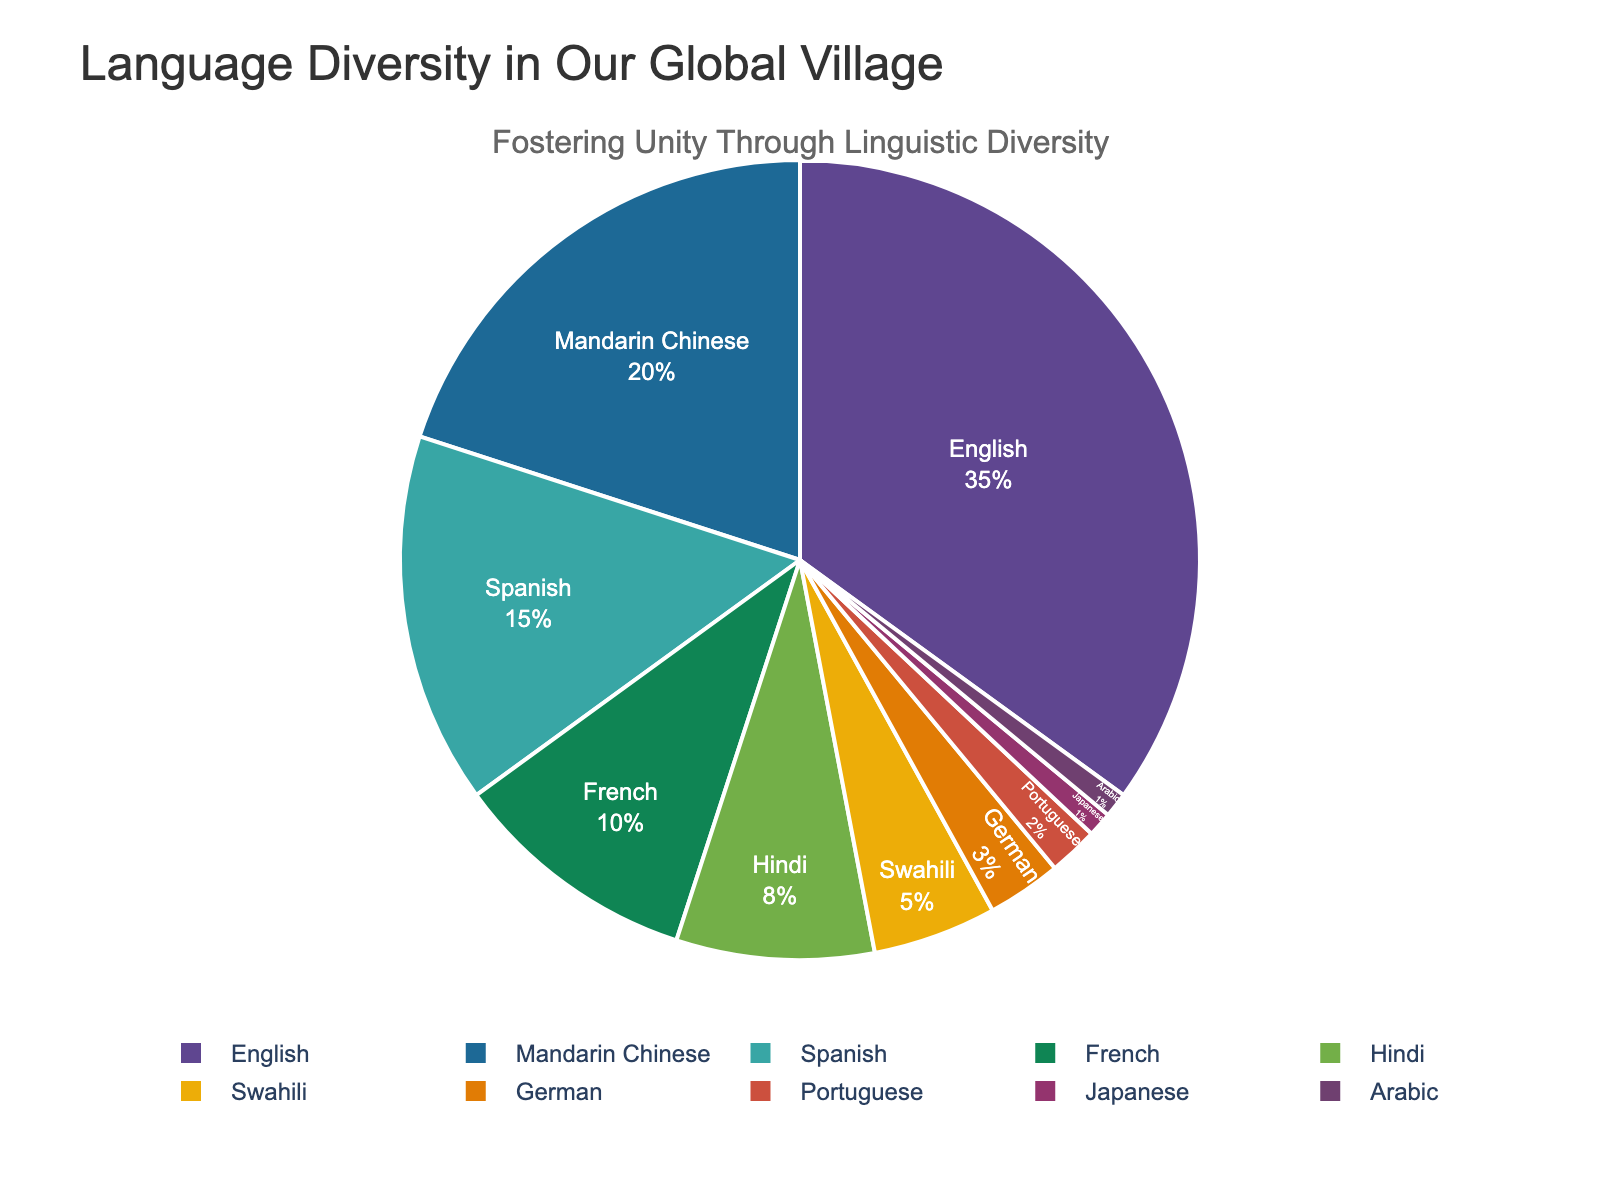What percentage of village residents speak English and Spanish combined? We need to sum the percentages for English and Spanish. English is 35% and Spanish is 15%. Adding these gives 35% + 15% = 50%.
Answer: 50 Which language is spoken by a higher percentage of residents, French or Hindi? We compare the percentages of French and Hindi. French is at 10% while Hindi is at 8%. Since 10% is greater than 8%, French is spoken by a higher percentage.
Answer: French How many languages are spoken by less than 5% of the residents? We count the languages with a percentage below 5%. The languages are German (3%), Portuguese (2%), Japanese (1%), and Arabic (1%). This gives us 4 languages.
Answer: 4 What is the difference in percentage between those who speak Mandarin Chinese and those who speak Spanish? Subtract the smaller percentage (Spanish) from the larger percentage (Mandarin Chinese). Mandarin Chinese is 20% and Spanish is 15%. The difference is 20% - 15% = 5%.
Answer: 5 Which language spoken by village residents has the smallest percentage representation? We look for the language with the smallest percentage in the chart. Both Japanese and Arabic are at 1%, which is the lowest percentage mentioned.
Answer: Japanese, Arabic Are there more residents who speak Hindi or those who speak Swahili? We compare the percentages for Hindi and Swahili. Hindi is at 8% while Swahili is at 5%. Since 8% is greater than 5%, more residents speak Hindi.
Answer: Hindi What is the combined percentage of residents who speak languages other than English, Mandarin Chinese, and Spanish? Sum the percentages of all languages except English, Mandarin Chinese, and Spanish. Those languages are French (10%), Hindi (8%), Swahili (5%), German (3%), Portuguese (2%), Japanese (1%), and Arabic (1%). The combined percentage is 10% + 8% + 5% + 3% + 2% + 1% + 1% = 30%.
Answer: 30 What color is used to represent the language spoken by 35% of residents? Review the pie chart and identify the color corresponding to the segment representing 35%, which is English. The color assigned to this segment is visually identifiable in the chart.
Answer: (Note: Since the exact colors are not provided, this part remains open-ended for actual visualization.) Is the percentage of residents that speak French equal to the sum of those who speak Japanese and Arabic? Compare the percentage of French (10%) with the sum of Japanese (1%) and Arabic (1%). The sum is 1% + 1% = 2%, which is not equal to 10%.
Answer: No 